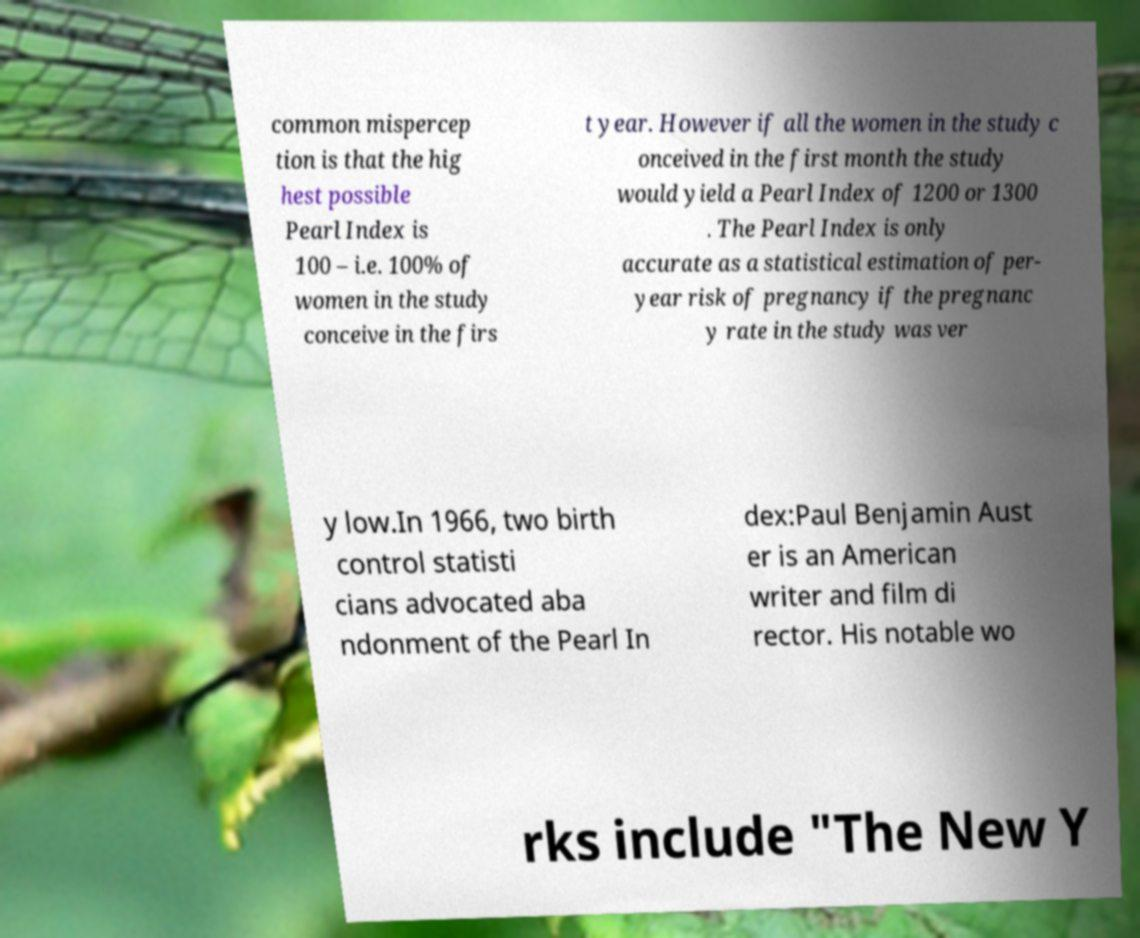Can you accurately transcribe the text from the provided image for me? common mispercep tion is that the hig hest possible Pearl Index is 100 – i.e. 100% of women in the study conceive in the firs t year. However if all the women in the study c onceived in the first month the study would yield a Pearl Index of 1200 or 1300 . The Pearl Index is only accurate as a statistical estimation of per- year risk of pregnancy if the pregnanc y rate in the study was ver y low.In 1966, two birth control statisti cians advocated aba ndonment of the Pearl In dex:Paul Benjamin Aust er is an American writer and film di rector. His notable wo rks include "The New Y 